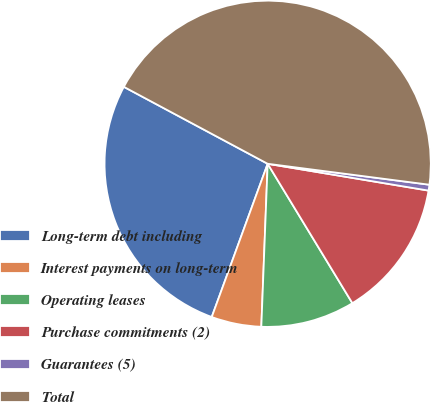Convert chart to OTSL. <chart><loc_0><loc_0><loc_500><loc_500><pie_chart><fcel>Long-term debt including<fcel>Interest payments on long-term<fcel>Operating leases<fcel>Purchase commitments (2)<fcel>Guarantees (5)<fcel>Total<nl><fcel>27.25%<fcel>4.95%<fcel>9.31%<fcel>13.68%<fcel>0.58%<fcel>44.23%<nl></chart> 